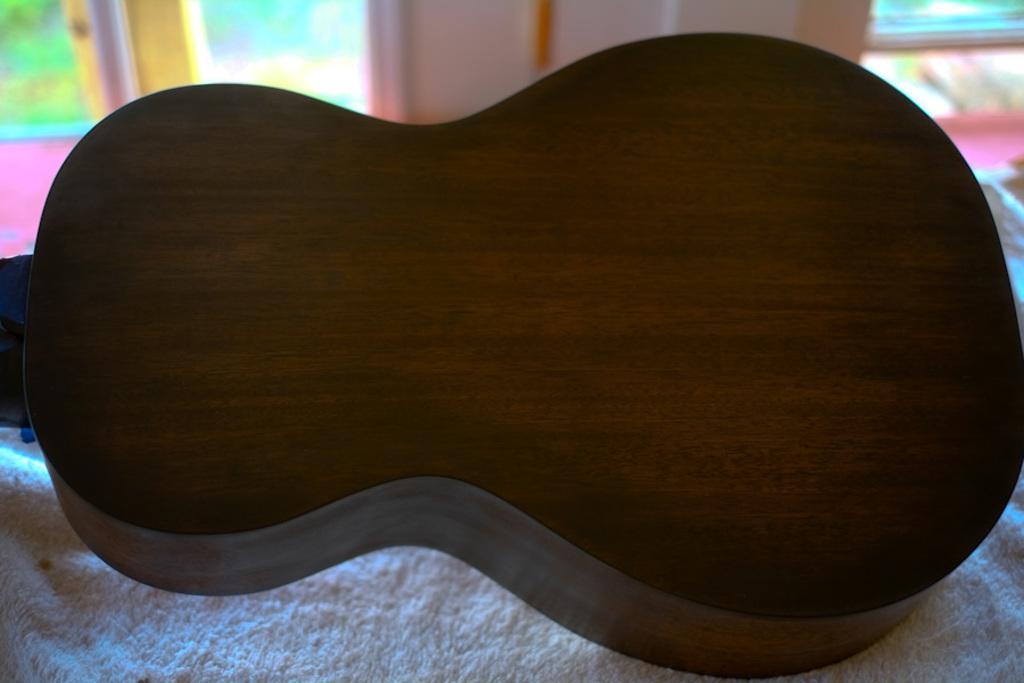How would you summarize this image in a sentence or two? In this image I can see the backside part of the guitar. This part it looks like a wooden texture. This guitar is placed on the blanket which is white in color. And the background looks colorful. 